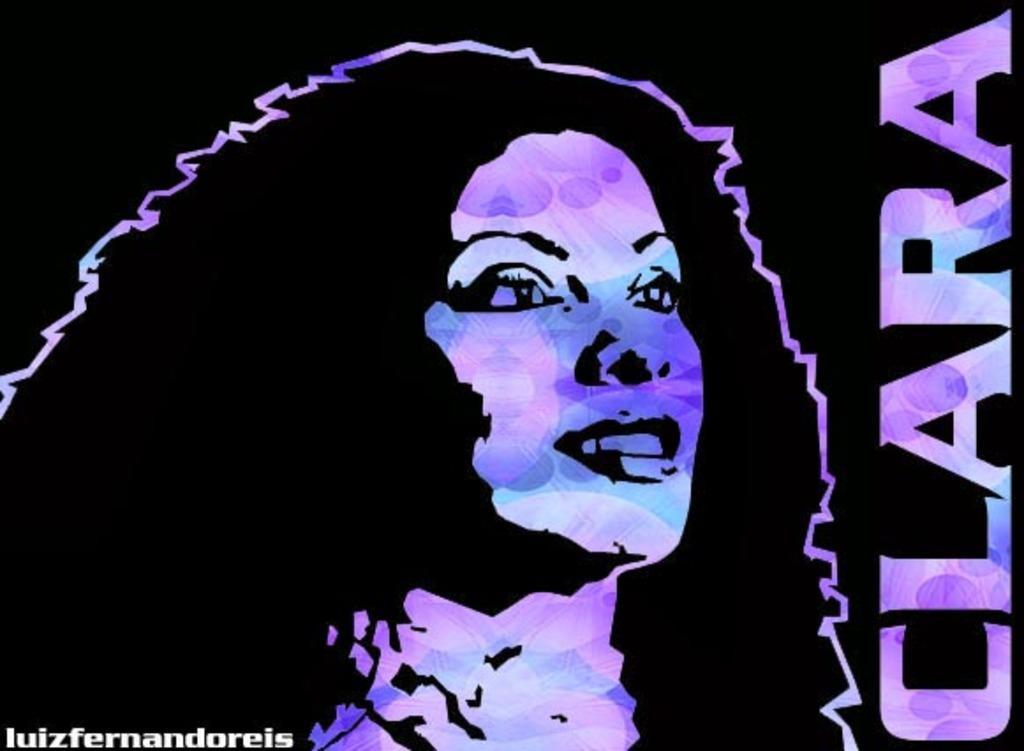Can you describe this image briefly? In the picture we can see an animated painting of a woman and beside it, we can see a name CLARA. 